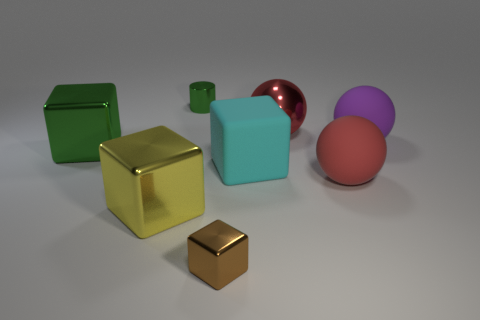Are there more tiny green things that are in front of the tiny green metallic object than red objects that are on the right side of the big purple matte object?
Give a very brief answer. No. Is the color of the ball that is behind the big purple ball the same as the big rubber ball that is behind the big green block?
Offer a terse response. No. What is the shape of the yellow shiny thing that is the same size as the cyan rubber block?
Give a very brief answer. Cube. Are there any large gray metallic objects of the same shape as the yellow thing?
Give a very brief answer. No. Do the small object on the right side of the tiny green metal cylinder and the green thing that is to the left of the green cylinder have the same material?
Offer a very short reply. Yes. What shape is the metallic thing that is the same color as the metal cylinder?
Provide a succinct answer. Cube. How many big red balls are made of the same material as the small green cylinder?
Make the answer very short. 1. What color is the metallic ball?
Your answer should be compact. Red. Do the green object that is in front of the large purple matte object and the shiny thing in front of the yellow cube have the same shape?
Your answer should be very brief. Yes. There is a large cube that is right of the tiny brown metallic thing; what color is it?
Ensure brevity in your answer.  Cyan. 